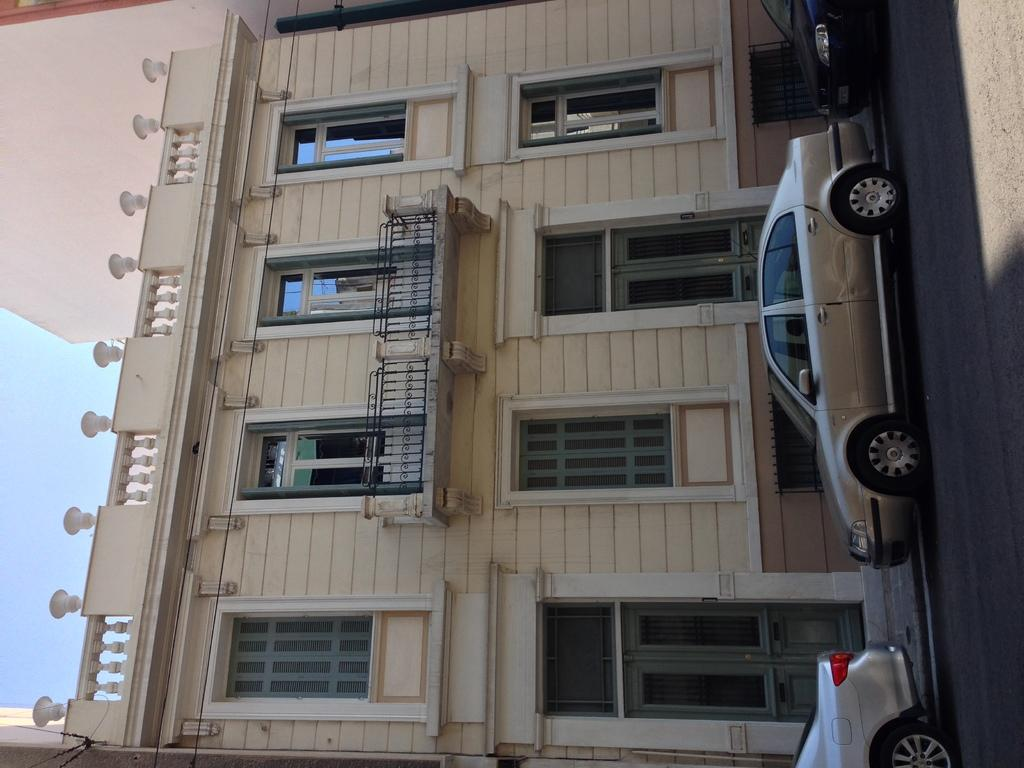What is happening on the right side of the image? There are vehicles moving on the road on the right side of the image. What can be seen in the middle of the image? There is a building in the middle of the image. What is visible on the left side of the image? The sky is visible on the left side of the image. Can you see any boats in the image? There are no boats present in the image. What type of regret is depicted in the image? There is no depiction of regret in the image. 